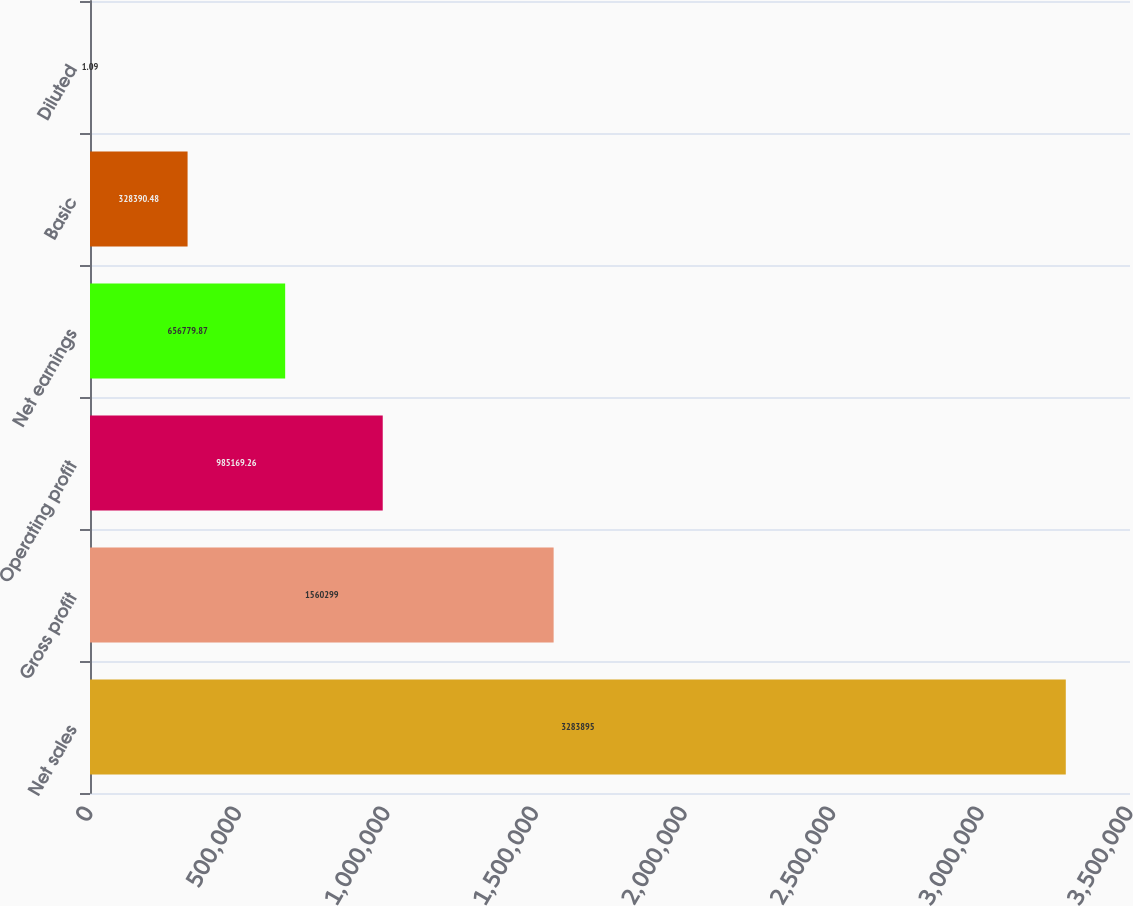Convert chart to OTSL. <chart><loc_0><loc_0><loc_500><loc_500><bar_chart><fcel>Net sales<fcel>Gross profit<fcel>Operating profit<fcel>Net earnings<fcel>Basic<fcel>Diluted<nl><fcel>3.2839e+06<fcel>1.5603e+06<fcel>985169<fcel>656780<fcel>328390<fcel>1.09<nl></chart> 